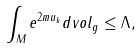Convert formula to latex. <formula><loc_0><loc_0><loc_500><loc_500>\int _ { M } e ^ { 2 m u _ { k } } d v o l _ { g } \leq \Lambda ,</formula> 